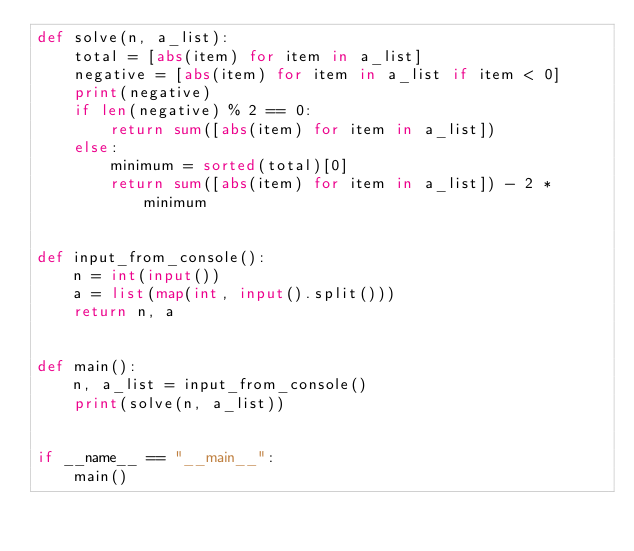<code> <loc_0><loc_0><loc_500><loc_500><_Python_>def solve(n, a_list):
    total = [abs(item) for item in a_list]
    negative = [abs(item) for item in a_list if item < 0]
    print(negative)
    if len(negative) % 2 == 0:
        return sum([abs(item) for item in a_list])
    else:
        minimum = sorted(total)[0]
        return sum([abs(item) for item in a_list]) - 2 * minimum


def input_from_console():
    n = int(input())
    a = list(map(int, input().split()))
    return n, a


def main():
    n, a_list = input_from_console()
    print(solve(n, a_list))


if __name__ == "__main__":
    main()
</code> 